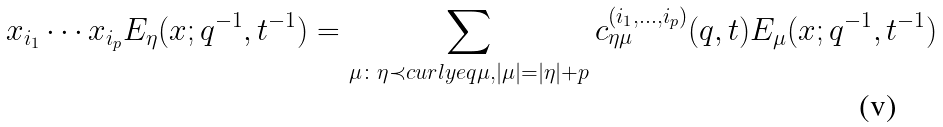<formula> <loc_0><loc_0><loc_500><loc_500>x _ { i _ { 1 } } \cdots x _ { i _ { p } } E _ { \eta } ( x ; q ^ { - 1 } , t ^ { - 1 } ) = \sum _ { \mu \colon \eta \prec c u r l y e q \mu , | \mu | = | \eta | + p } c _ { \eta \mu } ^ { ( i _ { 1 } , \dots , i _ { p } ) } ( q , t ) E _ { \mu } ( x ; q ^ { - 1 } , t ^ { - 1 } )</formula> 